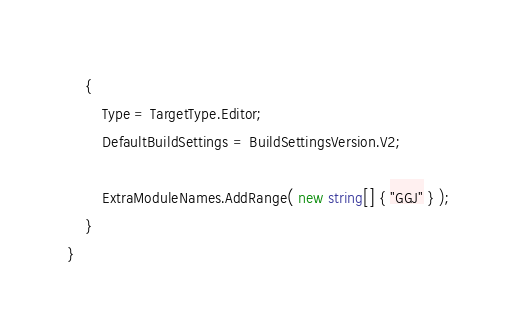Convert code to text. <code><loc_0><loc_0><loc_500><loc_500><_C#_>	{
		Type = TargetType.Editor;
		DefaultBuildSettings = BuildSettingsVersion.V2;

		ExtraModuleNames.AddRange( new string[] { "GGJ" } );
	}
}
</code> 